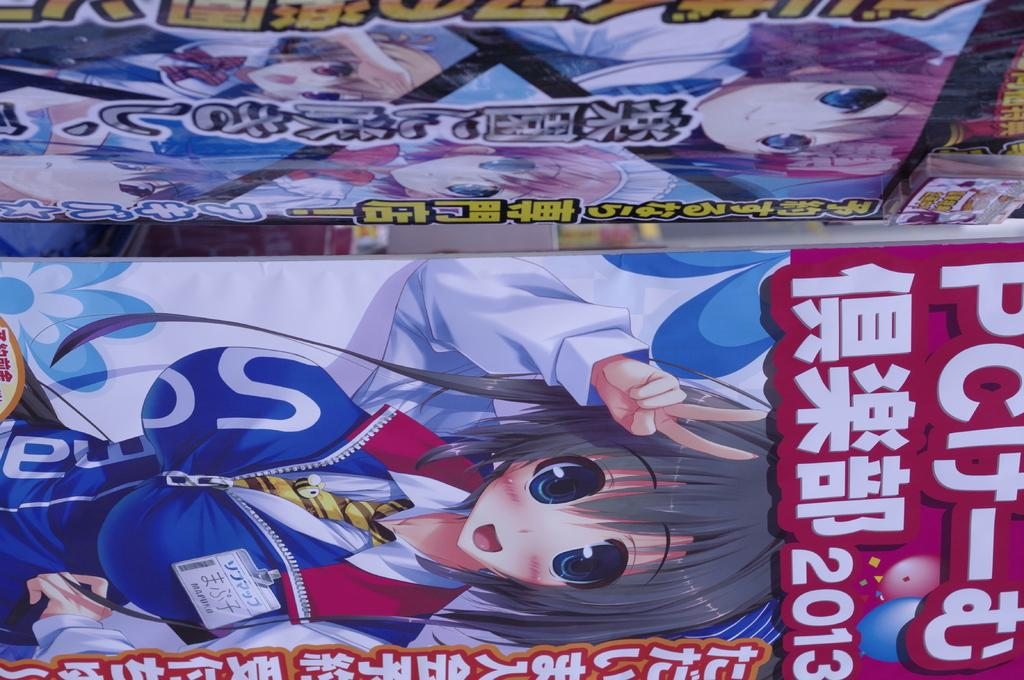How many boards are present in the image? There are two boards in the image. What is depicted on each board? Each board has an image of a cartoon. What else can be seen on the boards? There is text on each board. How many geese are present on the boards in the image? There are no geese depicted on the boards in the image; they feature cartoon images. What type of animal is shown interacting with the cartoon characters on the boards? There is no animal shown interacting with the cartoon characters on the boards; only the cartoon images and text are present. 